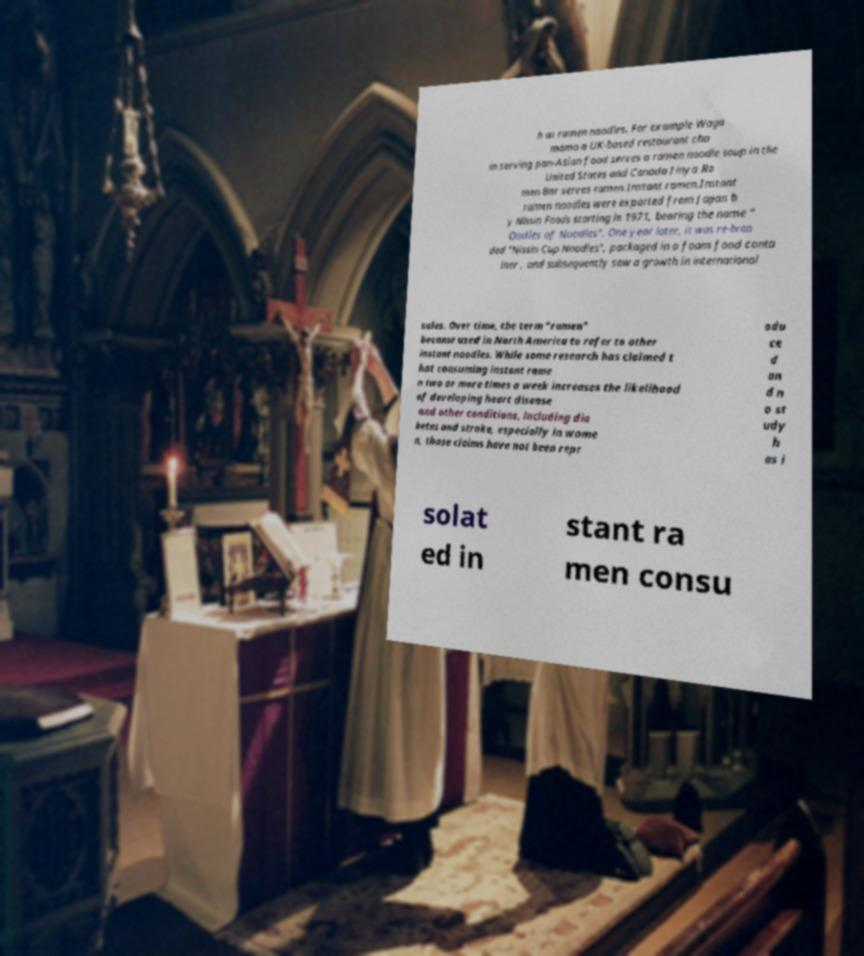For documentation purposes, I need the text within this image transcribed. Could you provide that? h as ramen noodles. For example Waga mama a UK-based restaurant cha in serving pan-Asian food serves a ramen noodle soup in the United States and Canada Jinya Ra men Bar serves ramen.Instant ramen.Instant ramen noodles were exported from Japan b y Nissin Foods starting in 1971, bearing the name " Oodles of Noodles". One year later, it was re-bran ded "Nissin Cup Noodles", packaged in a foam food conta iner , and subsequently saw a growth in international sales. Over time, the term "ramen" became used in North America to refer to other instant noodles. While some research has claimed t hat consuming instant rame n two or more times a week increases the likelihood of developing heart disease and other conditions, including dia betes and stroke, especially in wome n, those claims have not been repr odu ce d an d n o st udy h as i solat ed in stant ra men consu 